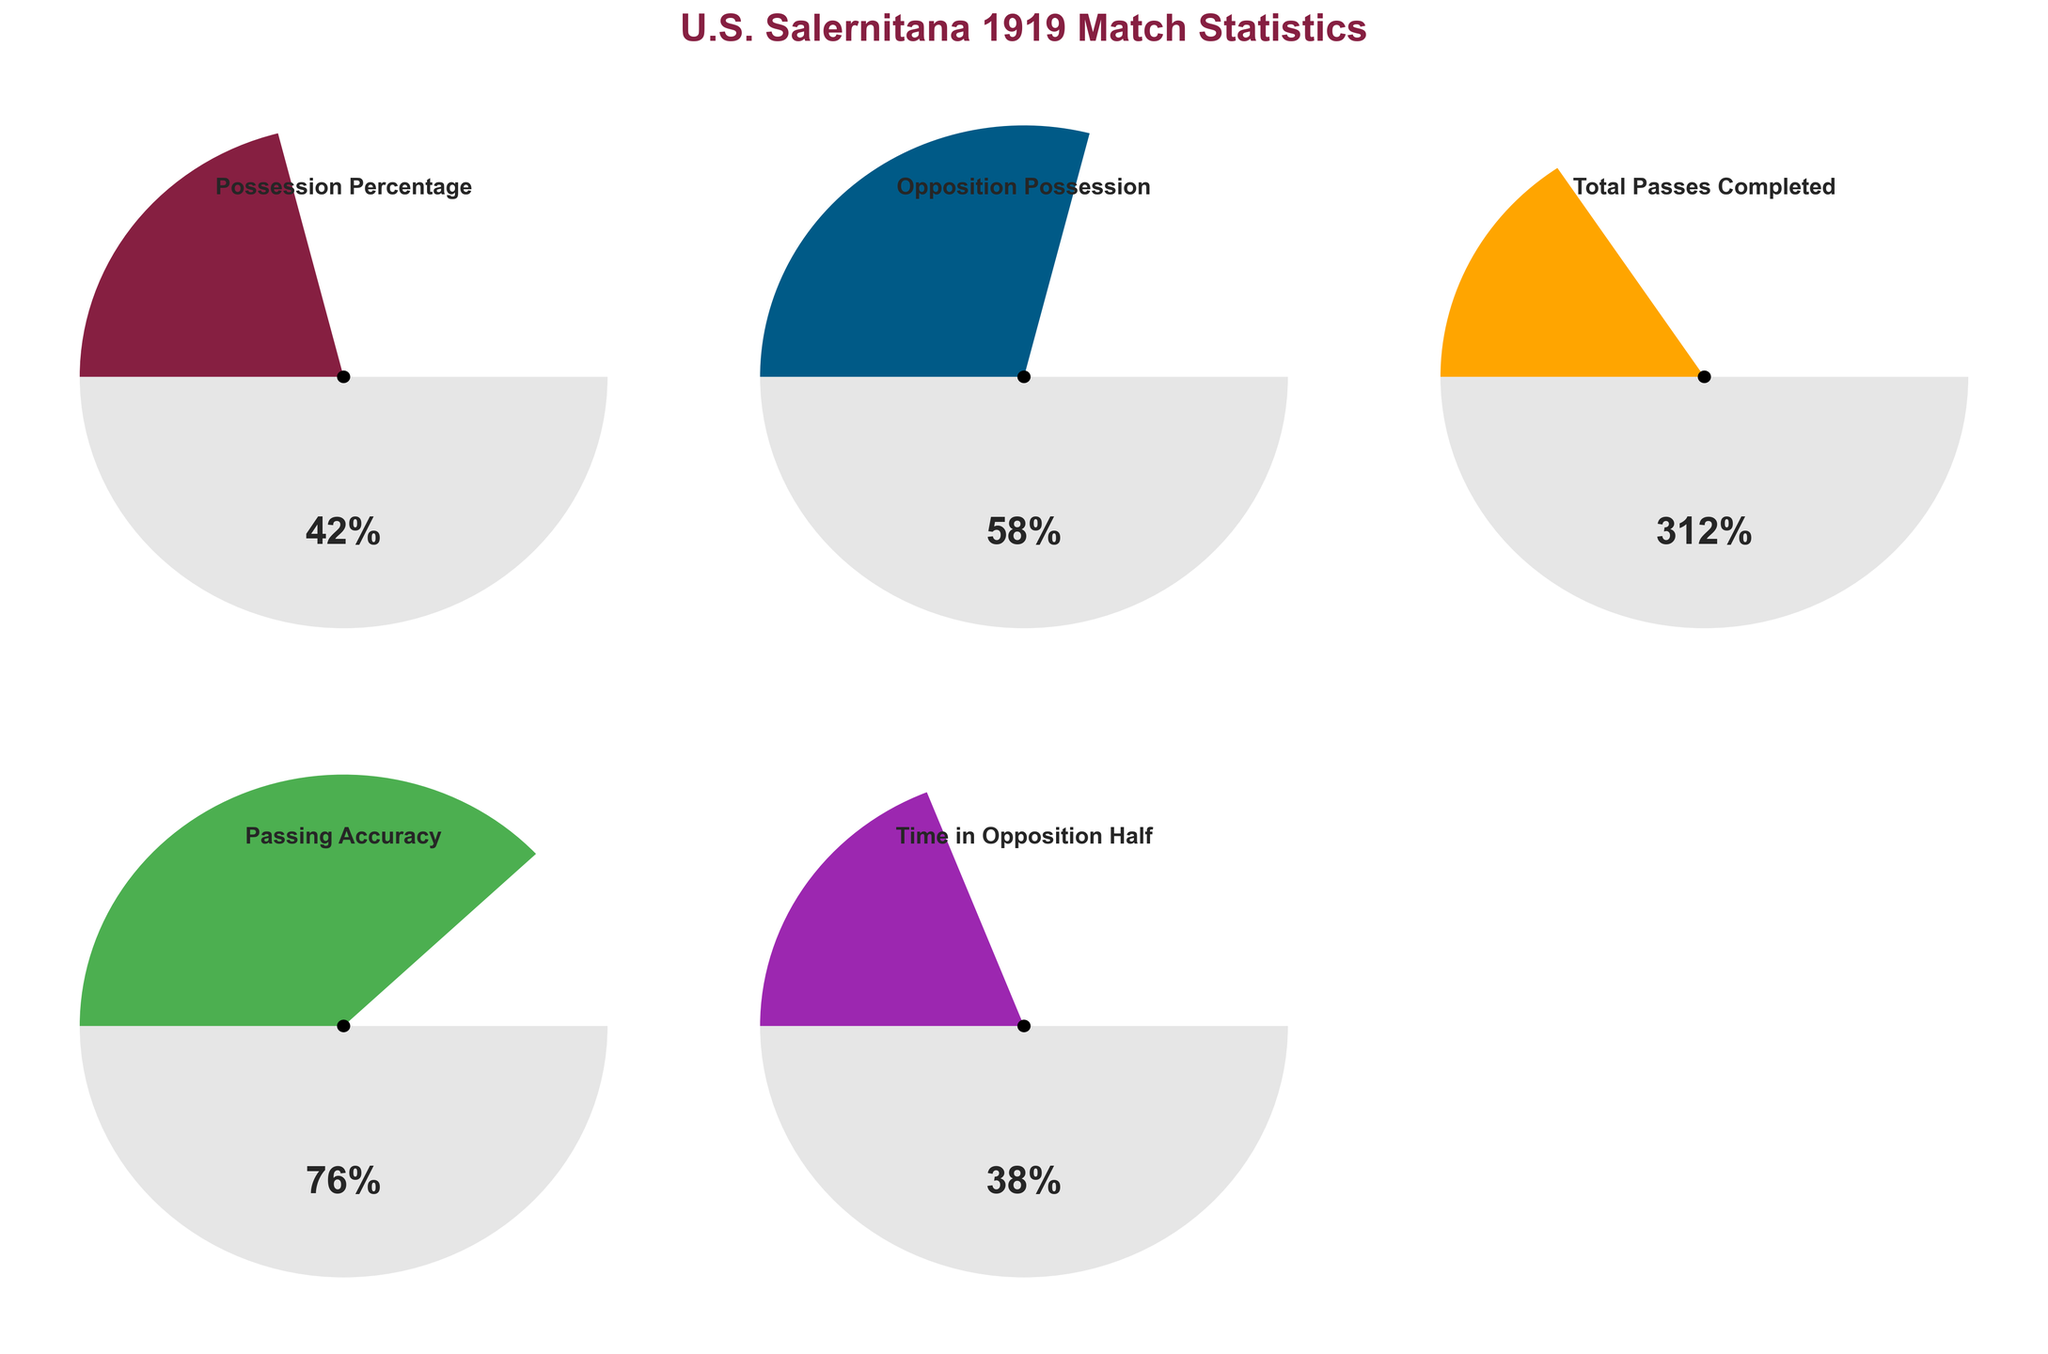How much possession did U.S. Salernitana 1919 have in their match? Look at the gauge chart for "Possession Percentage", which shows the percentage of possession time. The gauge indicates a value of 42%.
Answer: 42% Which team had higher possession, U.S. Salernitana 1919 or their opposition? Compare the "Possession Percentage" for U.S. Salernitana 1919 (42%) to the "Opposition Possession" (58%). The opposition had a higher possession percentage.
Answer: Opposition What is the total number of passes completed by U.S. Salernitana 1919? Look at the gauge chart titled "Total Passes Completed". It shows that the team completed 312 passes.
Answer: 312 What is the difference in possession percentage between U.S. Salernitana 1919 and their opposition? The possession percentage of U.S. Salernitana 1919 is 42%, and the opposition is 58%. The difference is 58% - 42% = 16%.
Answer: 16% What percentage of the time did U.S. Salernitana 1919 spend in the opposition half? Refer to the gauge chart titled "Time in Opposition Half". It shows a value of 38%.
Answer: 38% Which statistic has the highest value? Compare all the values: Possession Percentage (42%), Opposition Possession (58%), Total Passes Completed (312), Passing Accuracy (76%), Time in Opposition Half (38%). Opposition Possession has the highest value (58%).
Answer: Opposition Possession What is the passing accuracy percentage for U.S. Salernitana 1919? Look at the gauge chart labeled "Passing Accuracy". It indicates a passing accuracy of 76%.
Answer: 76% What is the range of possible values for possession percentage? The minimum value for "Possession Percentage" is 0%, and the maximum is 100%.
Answer: 0-100% How do the possession percentages of U.S. Salernitana 1919 and their opposition compare to a 50-50 possession split? U.S. Salernitana 1919 has 42% possession, whereas their opposition has 58%. A 50-50 possession split would mean both have 50%. Compare these to see that 42% is less than 50% and 58% is more than 50%.
Answer: U.S. Salernitana 1919 is less, Opposition is more What percentage of possession does U.S. Salernitana 1919 need to have an equal possession to their opposition? U.S. Salernitana 1919 currently has 42%, and the opposition has 58%. For equal possession, both teams need 50%. To catch up, Salernitana needs an additional 8% (50% - 42%).
Answer: 8% 